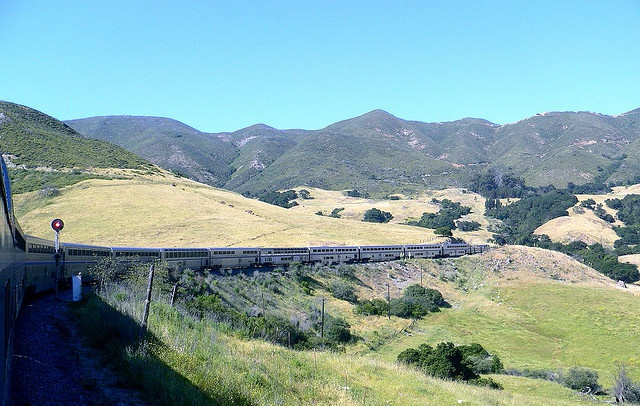Describe the objects in this image and their specific colors. I can see a train in lightblue, black, gray, navy, and blue tones in this image. 